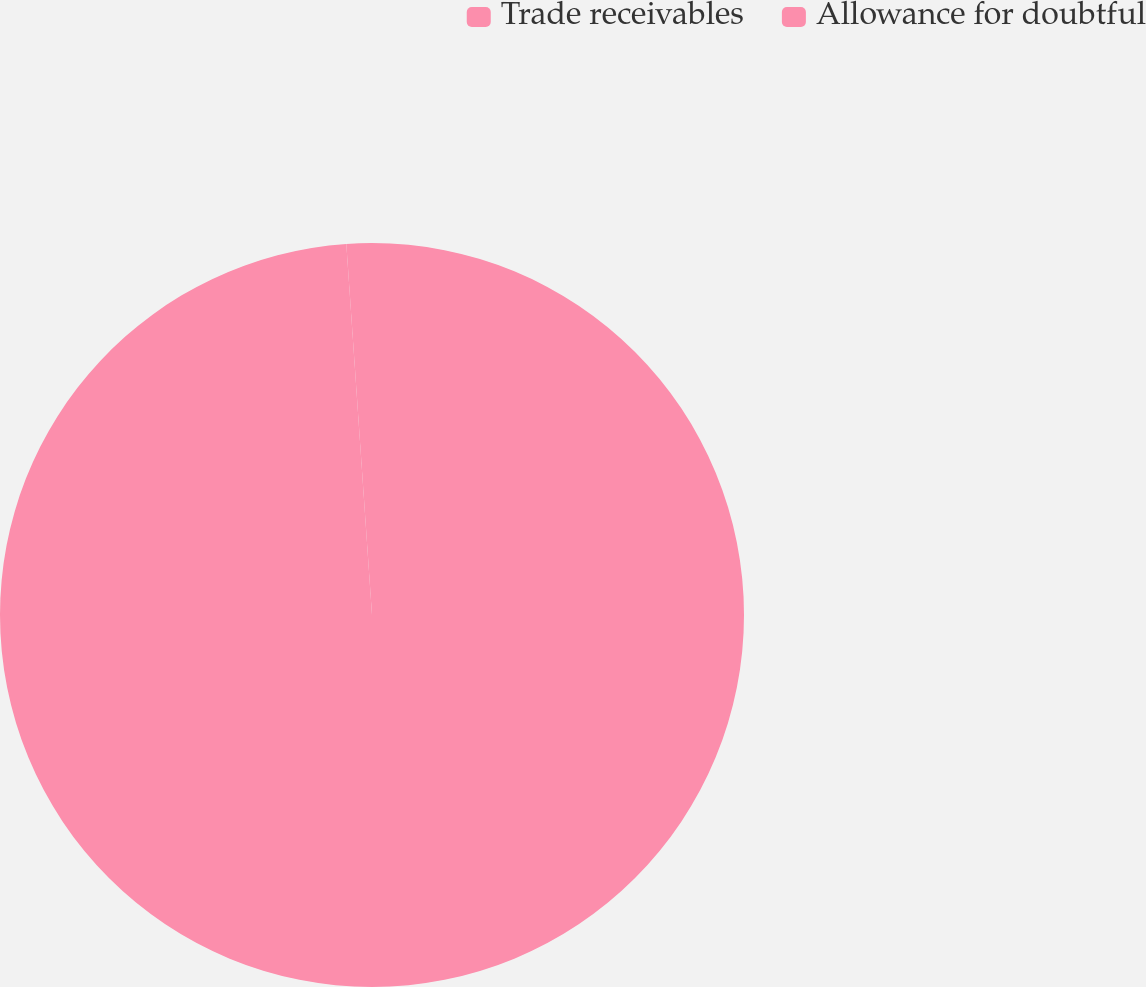Convert chart to OTSL. <chart><loc_0><loc_0><loc_500><loc_500><pie_chart><fcel>Trade receivables<fcel>Allowance for doubtful<nl><fcel>98.9%<fcel>1.1%<nl></chart> 